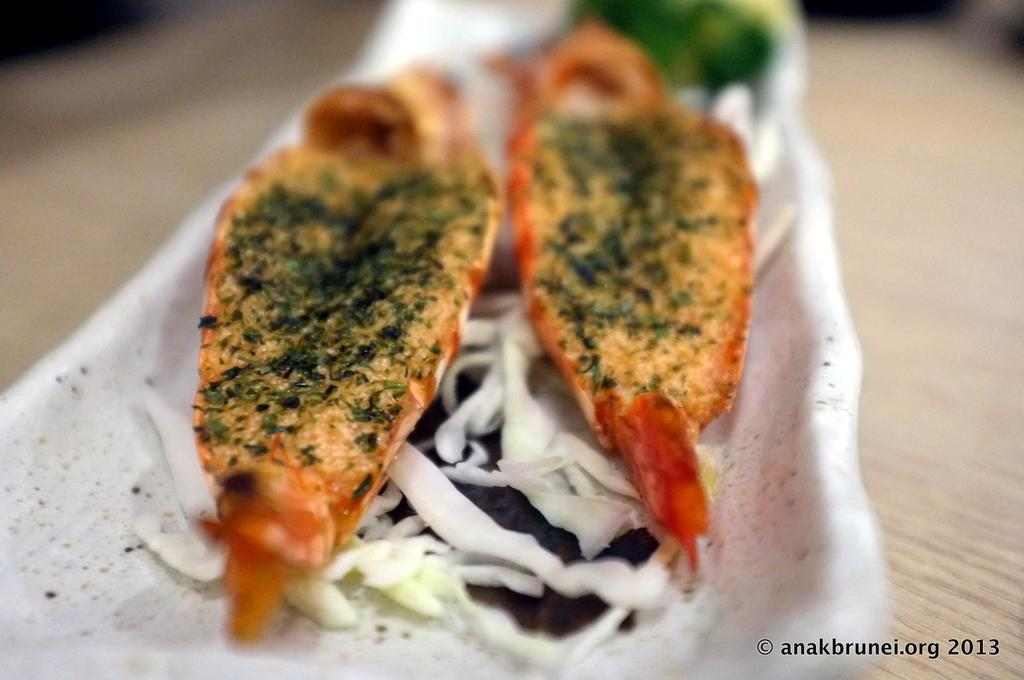What is on the white plate in the image? There is a food item in a white plate in the image. Where is the plate placed? The plate is placed on a wooden surface. What can be found in the bottom right corner of the image? There is text and a number in the bottom right corner of the image. What type of clouds can be seen in the image? There are no clouds present in the image. What is the result of the division operation in the image? There is no division operation present in the image. 